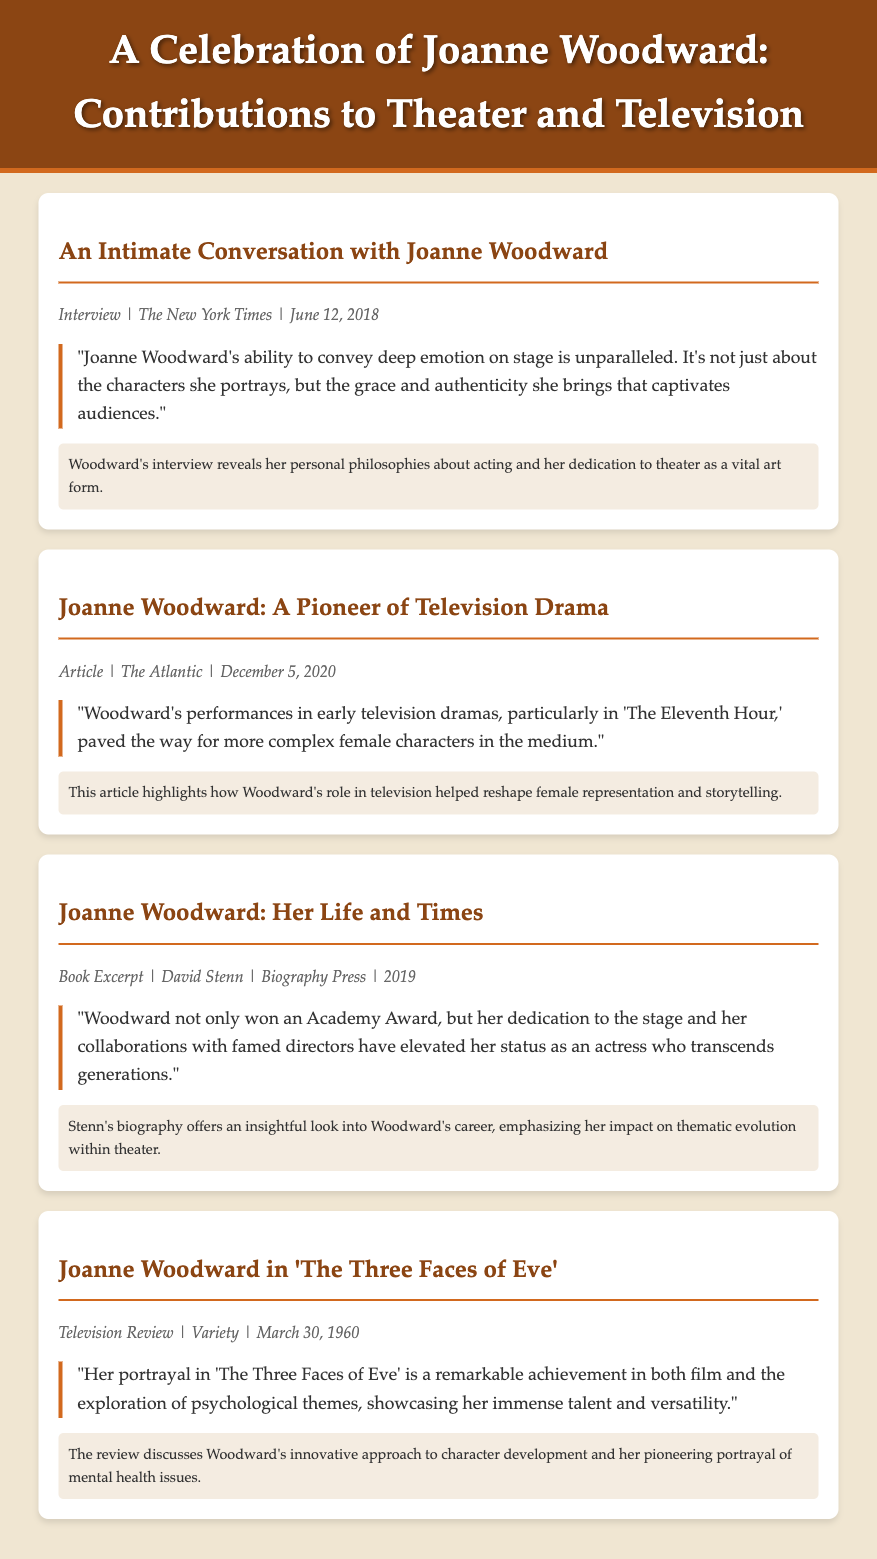What is the title of the document? The title is the main heading at the top of the document, summarizing its focus on Joanne Woodward's contributions.
Answer: A Celebration of Joanne Woodward: Contributions to Theater and Television When was the interview with Joanne Woodward published? The date of publication can be found in the material info section of the interview.
Answer: June 12, 2018 Which article highlights Joanne Woodward's impact on female representation in television? This information is provided in the title and commentary sections of the relevant article.
Answer: Joanne Woodward: A Pioneer of Television Drama What is one award mentioned that Joanne Woodward won? The specific award is noted in the book excerpt about her life.
Answer: Academy Award What psychological theme is discussed in relation to Joanne Woodward's role in 'The Three Faces of Eve'? This theme is mentioned in the review of her performance, which focuses on character development.
Answer: Psychological themes How has Joanne Woodward's contribution to theater been characterized in her interview? The interview emphasizes her personal philosophies and dedication to theater as an art form.
Answer: Grace and authenticity 